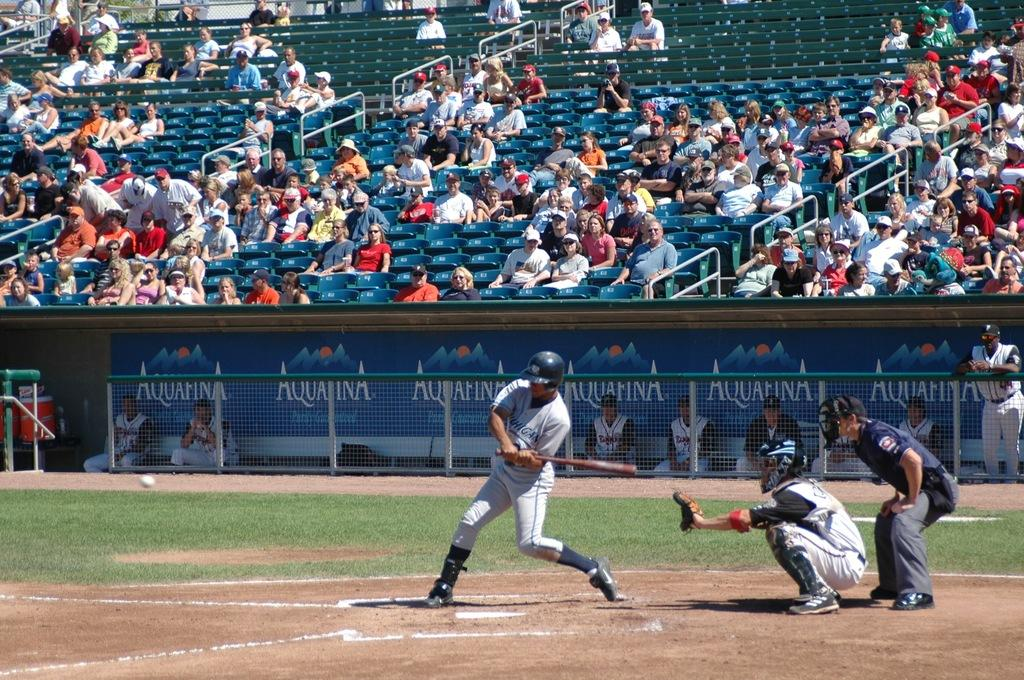<image>
Give a short and clear explanation of the subsequent image. A baseball player about to hit a ball with an advertisement for Aquafina behind him. 